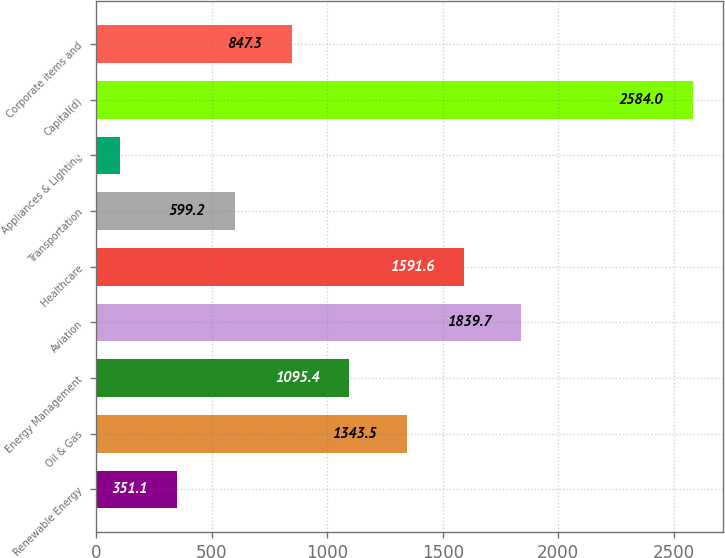Convert chart to OTSL. <chart><loc_0><loc_0><loc_500><loc_500><bar_chart><fcel>Renewable Energy<fcel>Oil & Gas<fcel>Energy Management<fcel>Aviation<fcel>Healthcare<fcel>Transportation<fcel>Appliances & Lighting<fcel>Capital(d)<fcel>Corporate items and<nl><fcel>351.1<fcel>1343.5<fcel>1095.4<fcel>1839.7<fcel>1591.6<fcel>599.2<fcel>103<fcel>2584<fcel>847.3<nl></chart> 